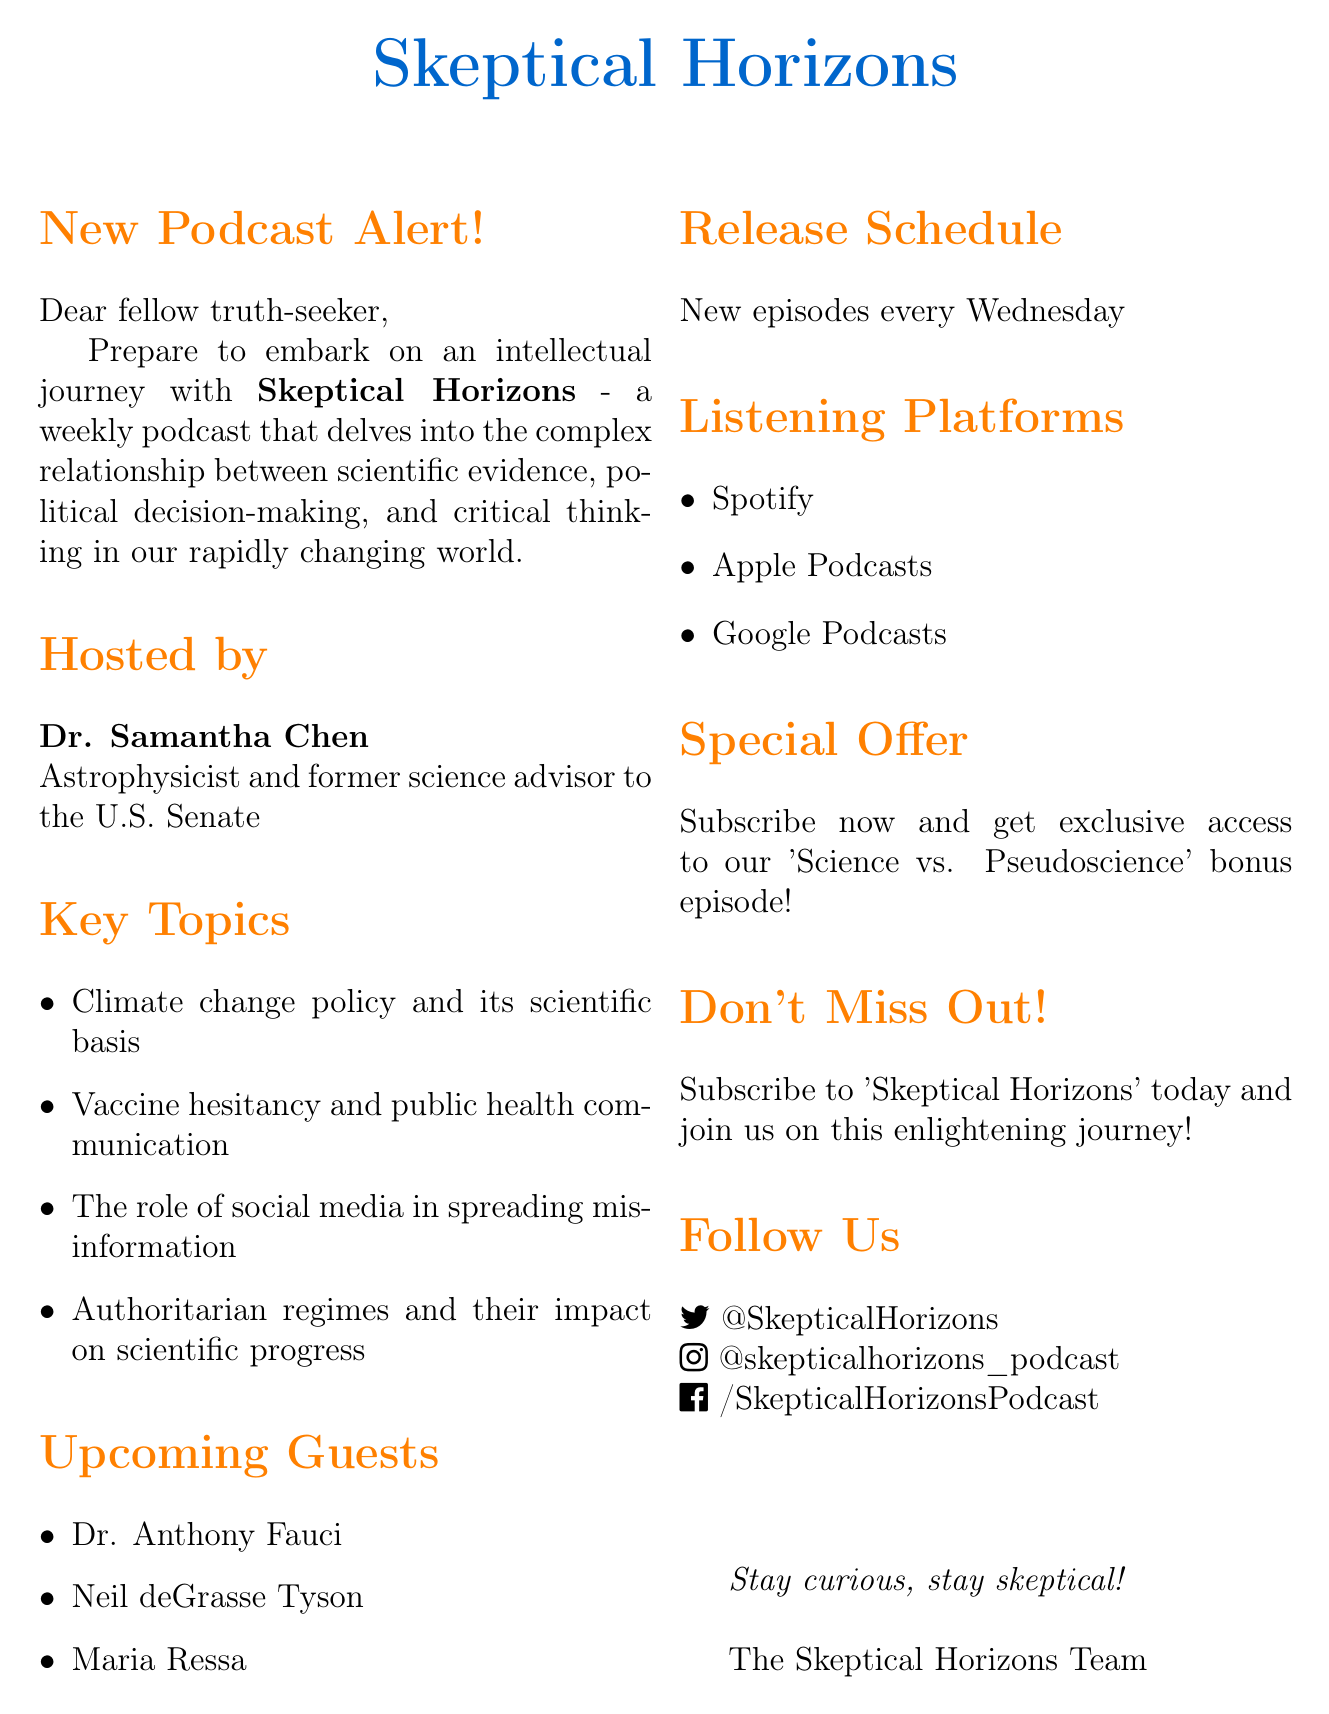What is the name of the podcast? The name of the podcast is explicitly mentioned in the document as "Skeptical Horizons."
Answer: Skeptical Horizons Who is the host of the podcast? The host's name is provided in the document, highlighting their credentials as well, which is "Dr. Samantha Chen."
Answer: Dr. Samantha Chen What is the release schedule for new episodes? The document specifies when new episodes will be available, stating they are released "every Wednesday."
Answer: Every Wednesday Name one upcoming guest on the podcast. The document lists upcoming guests, with "Dr. Anthony Fauci," "Neil deGrasse Tyson," and "Maria Ressa" mentioned as examples.
Answer: Dr. Anthony Fauci What is the special offer mentioned in the email? The document includes an exclusive offer for subscribers, specifically detailing access to a bonus episode titled "Science vs. Pseudoscience."
Answer: "Science vs. Pseudoscience" bonus episode Which platform can listeners use to subscribe to the podcast? The document provides a list of platforms for listeners to access the podcast, including "Spotify," "Apple Podcasts," and "Google Podcasts."
Answer: Spotify What type of content does the podcast focus on? The essence of the podcast's theme is summed up in the description, referring to the relationship between scientific evidence, political decision-making, and critical thinking.
Answer: Scientific evidence and political decision-making What is the call to action in the email? The document contains a clear directive for potential listeners, asking them to "subscribe to 'Skeptical Horizons' today!"
Answer: Subscribe to 'Skeptical Horizons' today! 